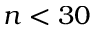<formula> <loc_0><loc_0><loc_500><loc_500>n < 3 0</formula> 